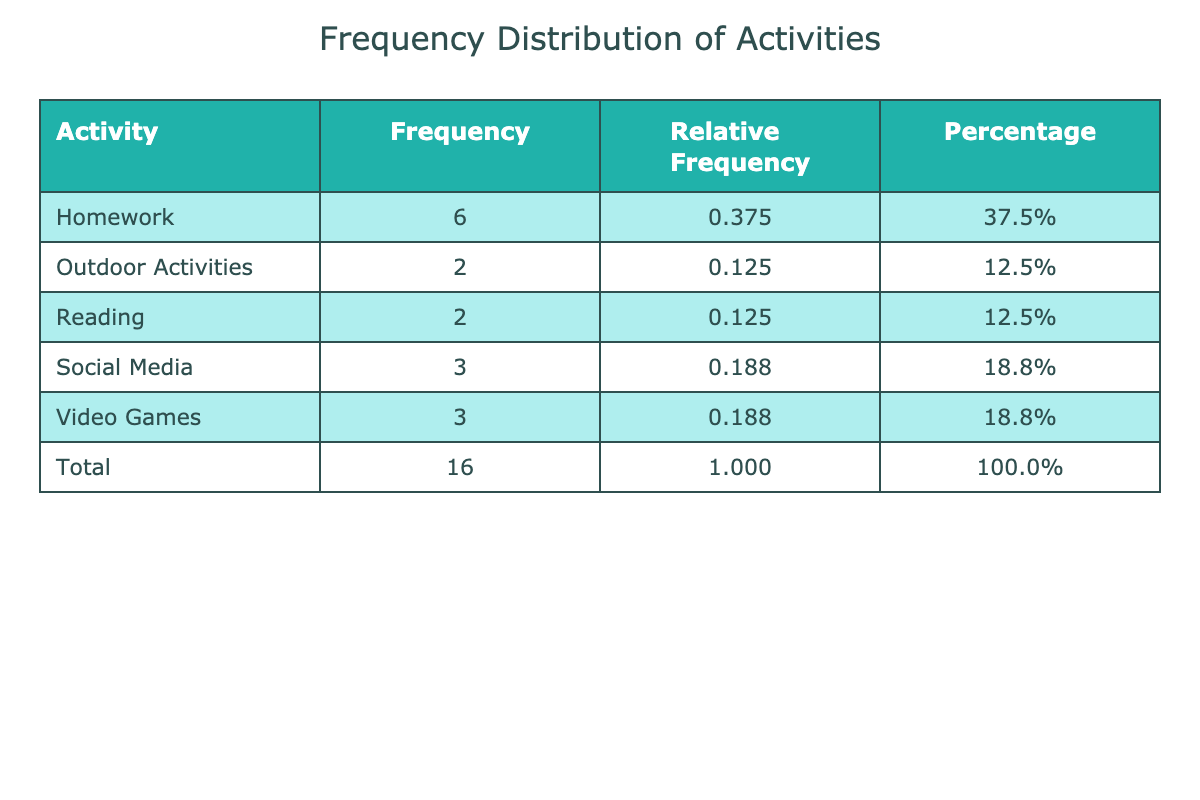What activity has the highest frequency? By looking at the frequency column of the table, we can see that "Homework" appears the most often with a frequency of 6.
Answer: Homework How many times did "Video Games" appear in the table? The frequency for "Video Games" is 3, which we can directly find in the frequency column of the table.
Answer: 3 What is the total number of activities recorded in the table? To find the total number of activities, we can look at the last row, which indicates a total of 16 activities.
Answer: 16 Which activity has a frequency of 2? We can check the frequency column to find any activities that have a frequency of 2. The activities "Reading," "Outdoor Activities," and "Social Media" each appear 2 times.
Answer: Reading, Outdoor Activities, Social Media What percentage of the total activities does "Social Media" represent? The frequency of "Social Media" is 3. We can calculate the percentage by using the formula (3/16) * 100, which equals 18.8%.
Answer: 18.8% What is the relative frequency of "Outdoor Activities"? The frequency of "Outdoor Activities" is 3. To find the relative frequency, we divide this by the total activities, giving us 3/16, which is 0.1875 or 0.188 when rounded.
Answer: 0.188 Is "Homework" more frequent than "Reading"? "Homework" has a frequency of 6 while "Reading" has a frequency of 2. Since 6 is greater than 2, we can conclude that "Homework" is indeed more frequent.
Answer: Yes What is the combined frequency of activities with a frequency greater than 3? We look at the frequency column and see that only "Video Games" (3) and "Homework" (6) have frequencies greater than 3. The combined frequency is 6 + 3 = 9.
Answer: 9 Which activity has the lowest frequency? We scan the frequency column to see that "Social Media" and "Reading" both appear 2 times, which is the least.
Answer: Social Media, Reading What is the average frequency of all the activities listed? To find the average, we add up all the frequencies (6 + 3 + 2 + 3 + 6 + 3 + 2 + 1 + 5 + 1 + 4 + 2 + 2 = 30) and divide by the number of unique activities (6: Homework, Video Games, Social Media, Outdoor Activities, Reading), giving us 30/6 = 5.
Answer: 5 